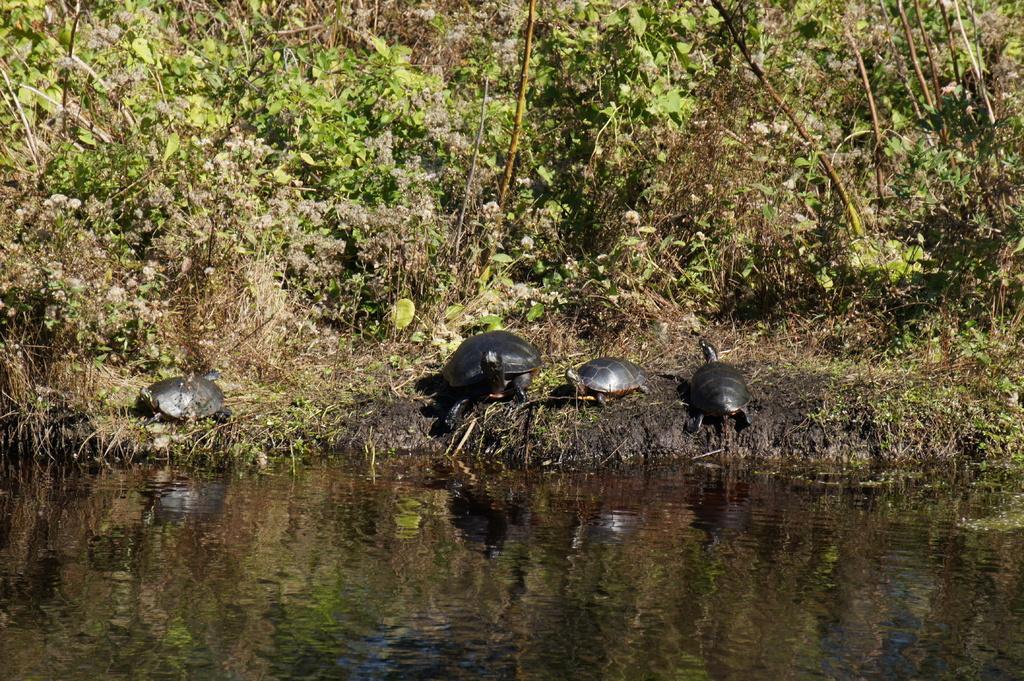In one or two sentences, can you explain what this image depicts? In this image I can see few tortoises, trees, grass and the water. 